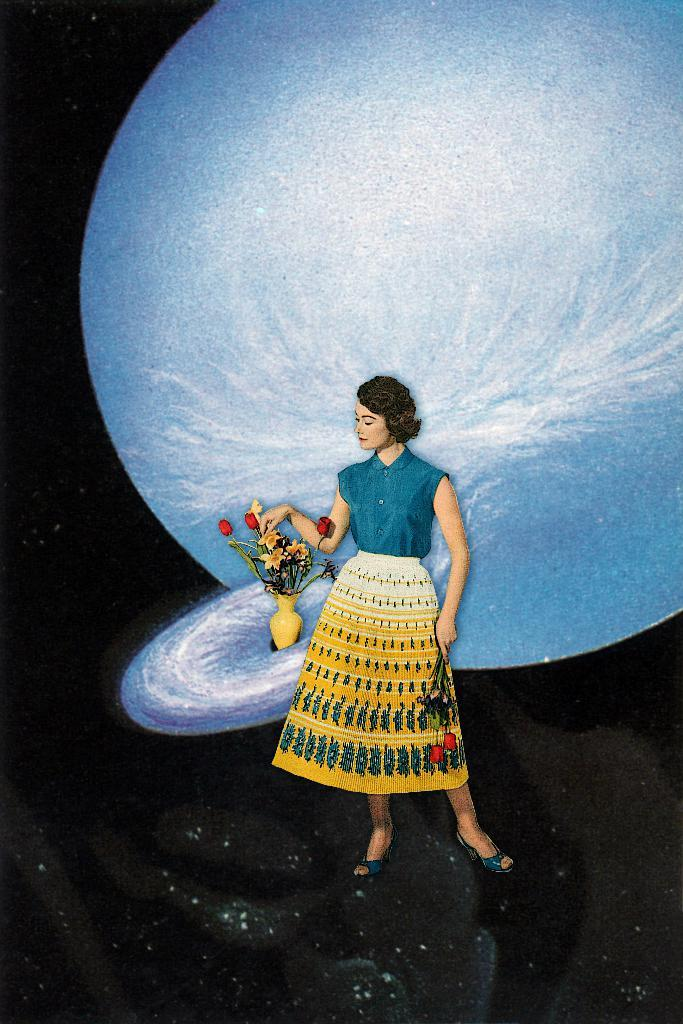Who is present in the image? There is a woman in the image. What object can be seen beside the woman? There is a flower vase in the image. What can be seen in the background of the image? There are planets in the background of the image. How would you describe the overall appearance of the image? The background of the image is dark. How does the woman balance the bridge in the image? There is no bridge present in the image, so the woman is not balancing a bridge. 